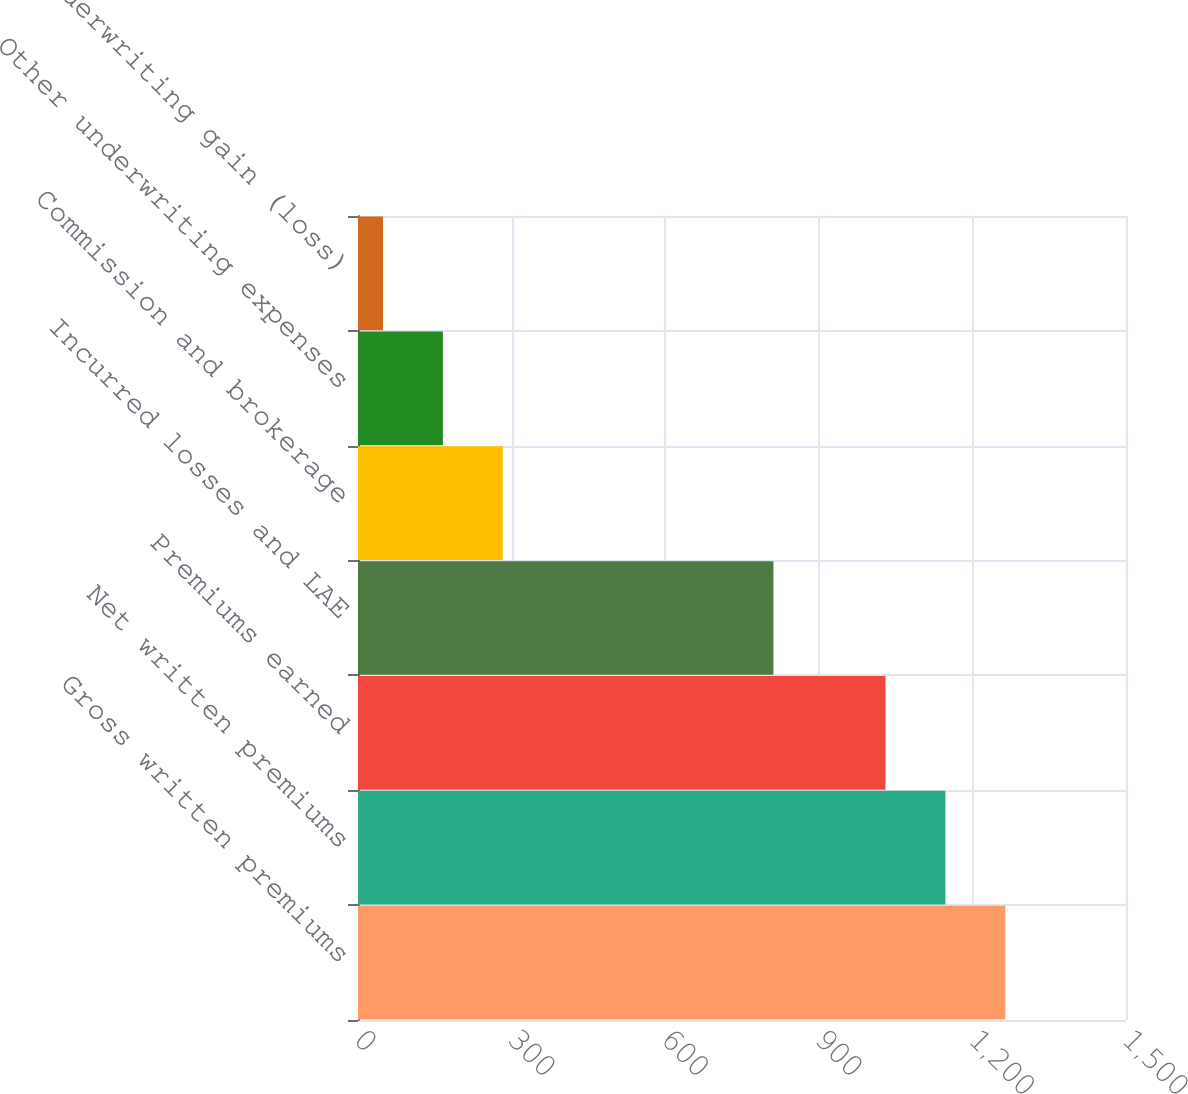Convert chart. <chart><loc_0><loc_0><loc_500><loc_500><bar_chart><fcel>Gross written premiums<fcel>Net written premiums<fcel>Premiums earned<fcel>Incurred losses and LAE<fcel>Commission and brokerage<fcel>Other underwriting expenses<fcel>Underwriting gain (loss)<nl><fcel>1264.2<fcel>1147.25<fcel>1030.3<fcel>811.4<fcel>282.8<fcel>165.85<fcel>48.9<nl></chart> 